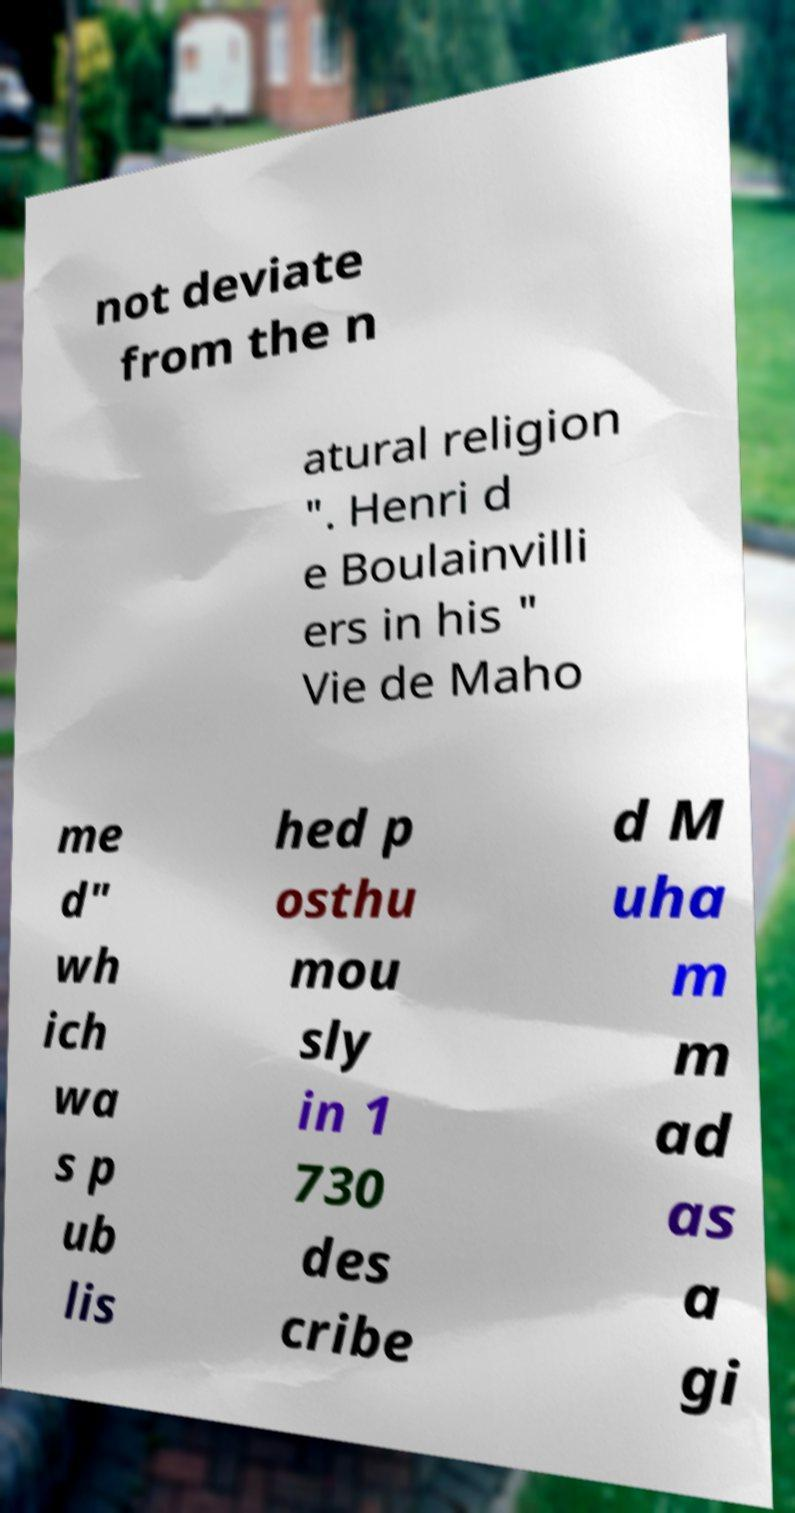There's text embedded in this image that I need extracted. Can you transcribe it verbatim? not deviate from the n atural religion ". Henri d e Boulainvilli ers in his " Vie de Maho me d" wh ich wa s p ub lis hed p osthu mou sly in 1 730 des cribe d M uha m m ad as a gi 